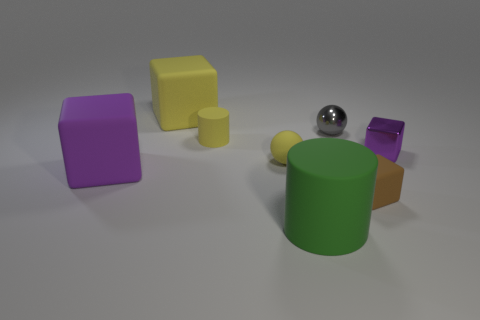Do the big matte object behind the shiny block and the small rubber sphere have the same color?
Provide a short and direct response. Yes. How many big things are in front of the rubber cylinder that is behind the big matte block in front of the big yellow rubber object?
Offer a terse response. 2. How many gray spheres are in front of the gray thing?
Give a very brief answer. 0. What is the color of the other thing that is the same shape as the big green thing?
Ensure brevity in your answer.  Yellow. There is a big object that is in front of the yellow cube and to the right of the purple matte thing; what material is it?
Your response must be concise. Rubber. Does the rubber object that is behind the gray metal ball have the same size as the tiny matte block?
Provide a succinct answer. No. What is the material of the tiny gray object?
Ensure brevity in your answer.  Metal. There is a big rubber cube that is behind the matte sphere; what color is it?
Make the answer very short. Yellow. How many large things are either green matte cylinders or rubber objects?
Your answer should be very brief. 3. Do the small metallic object in front of the small yellow cylinder and the large block that is in front of the metallic cube have the same color?
Ensure brevity in your answer.  Yes. 